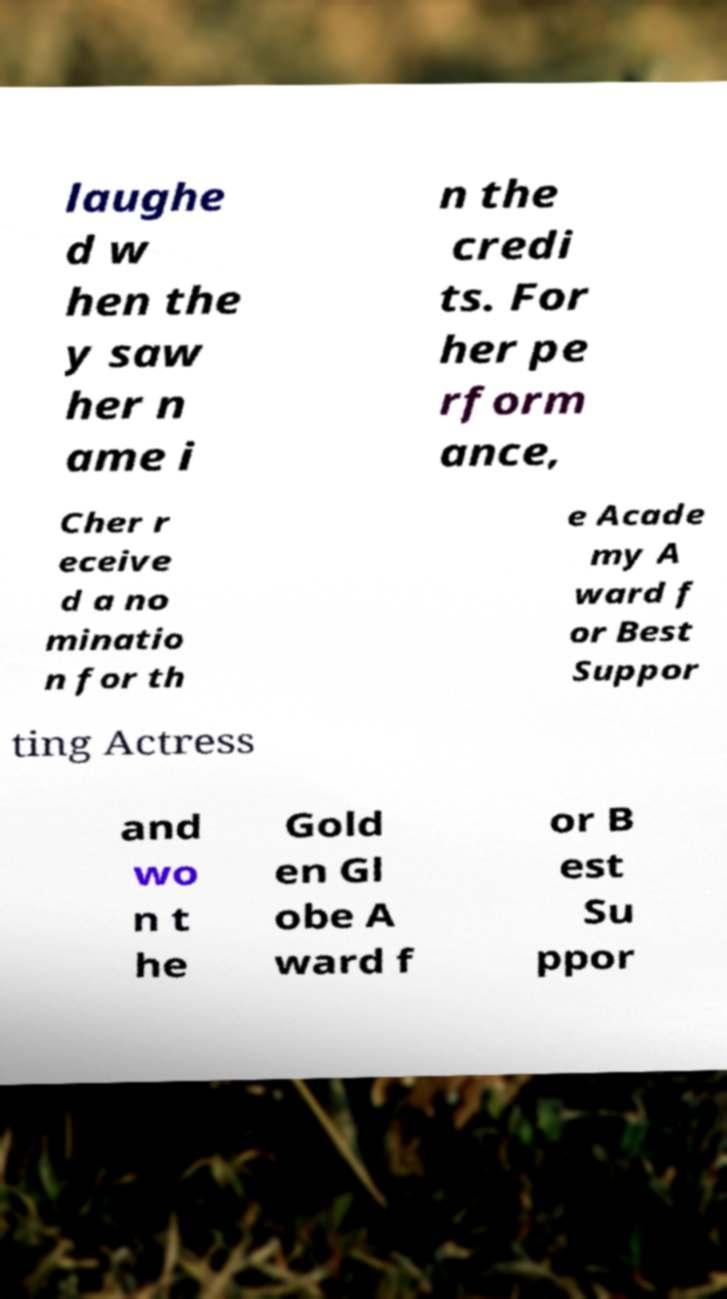Can you read and provide the text displayed in the image?This photo seems to have some interesting text. Can you extract and type it out for me? laughe d w hen the y saw her n ame i n the credi ts. For her pe rform ance, Cher r eceive d a no minatio n for th e Acade my A ward f or Best Suppor ting Actress and wo n t he Gold en Gl obe A ward f or B est Su ppor 